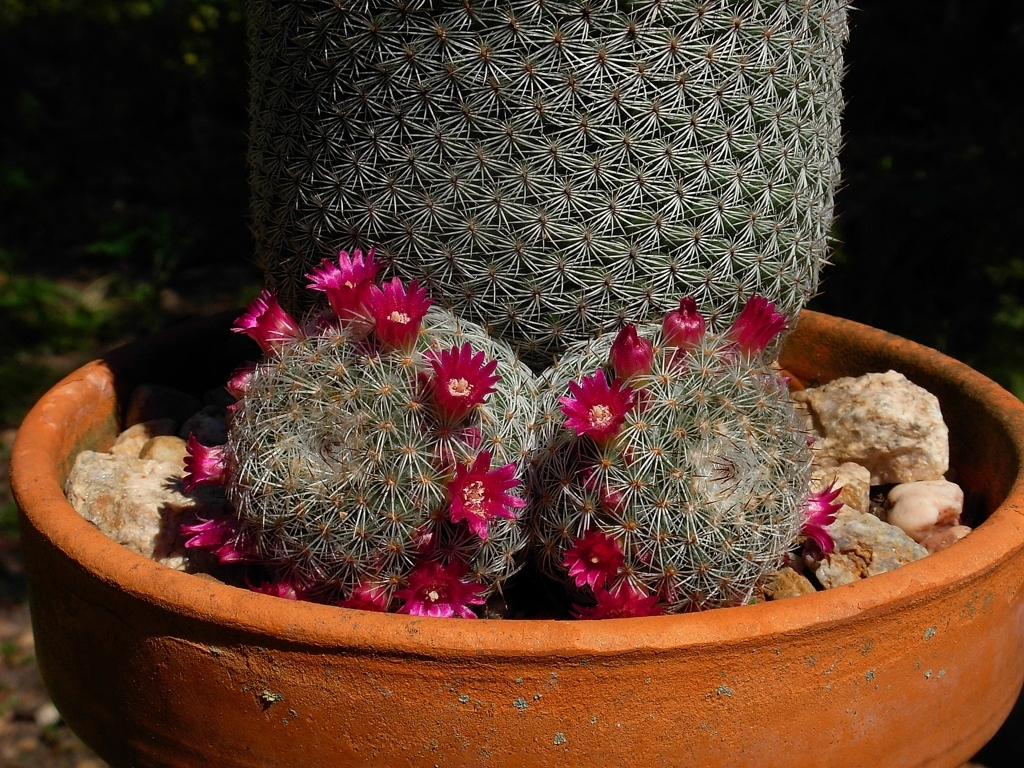Is the texture of the flower petals clear?
A. No
B. Yes
Answer with the option's letter from the given choices directly.
 B. 